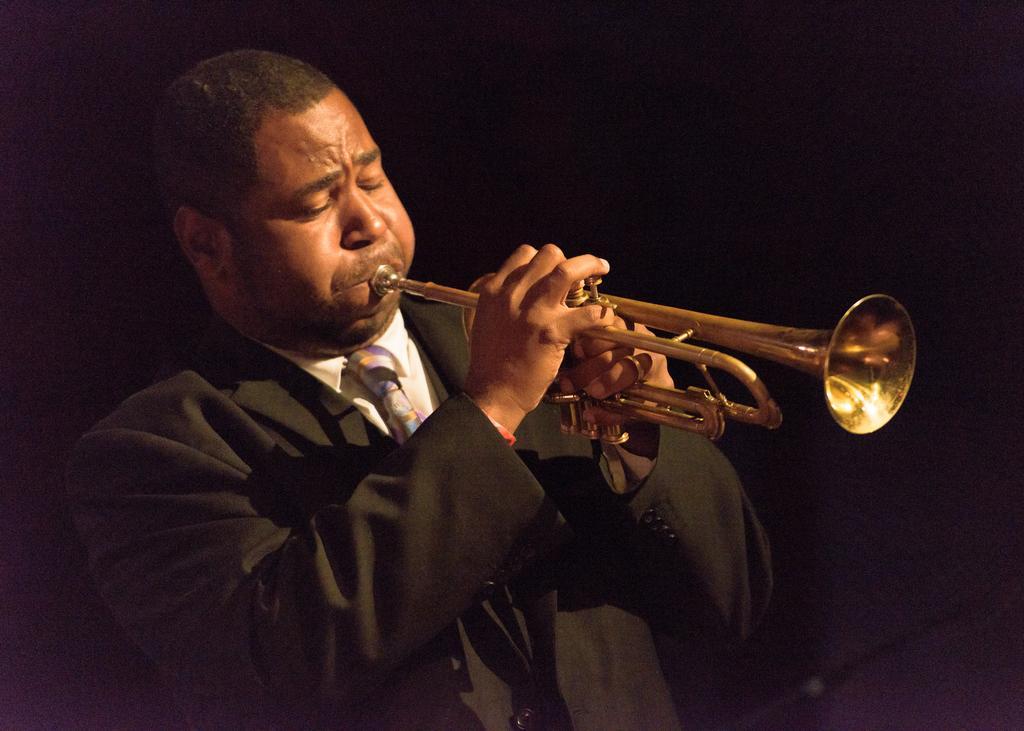In one or two sentences, can you explain what this image depicts? In this image there is a person playing a musical instrument. The background is dark. 